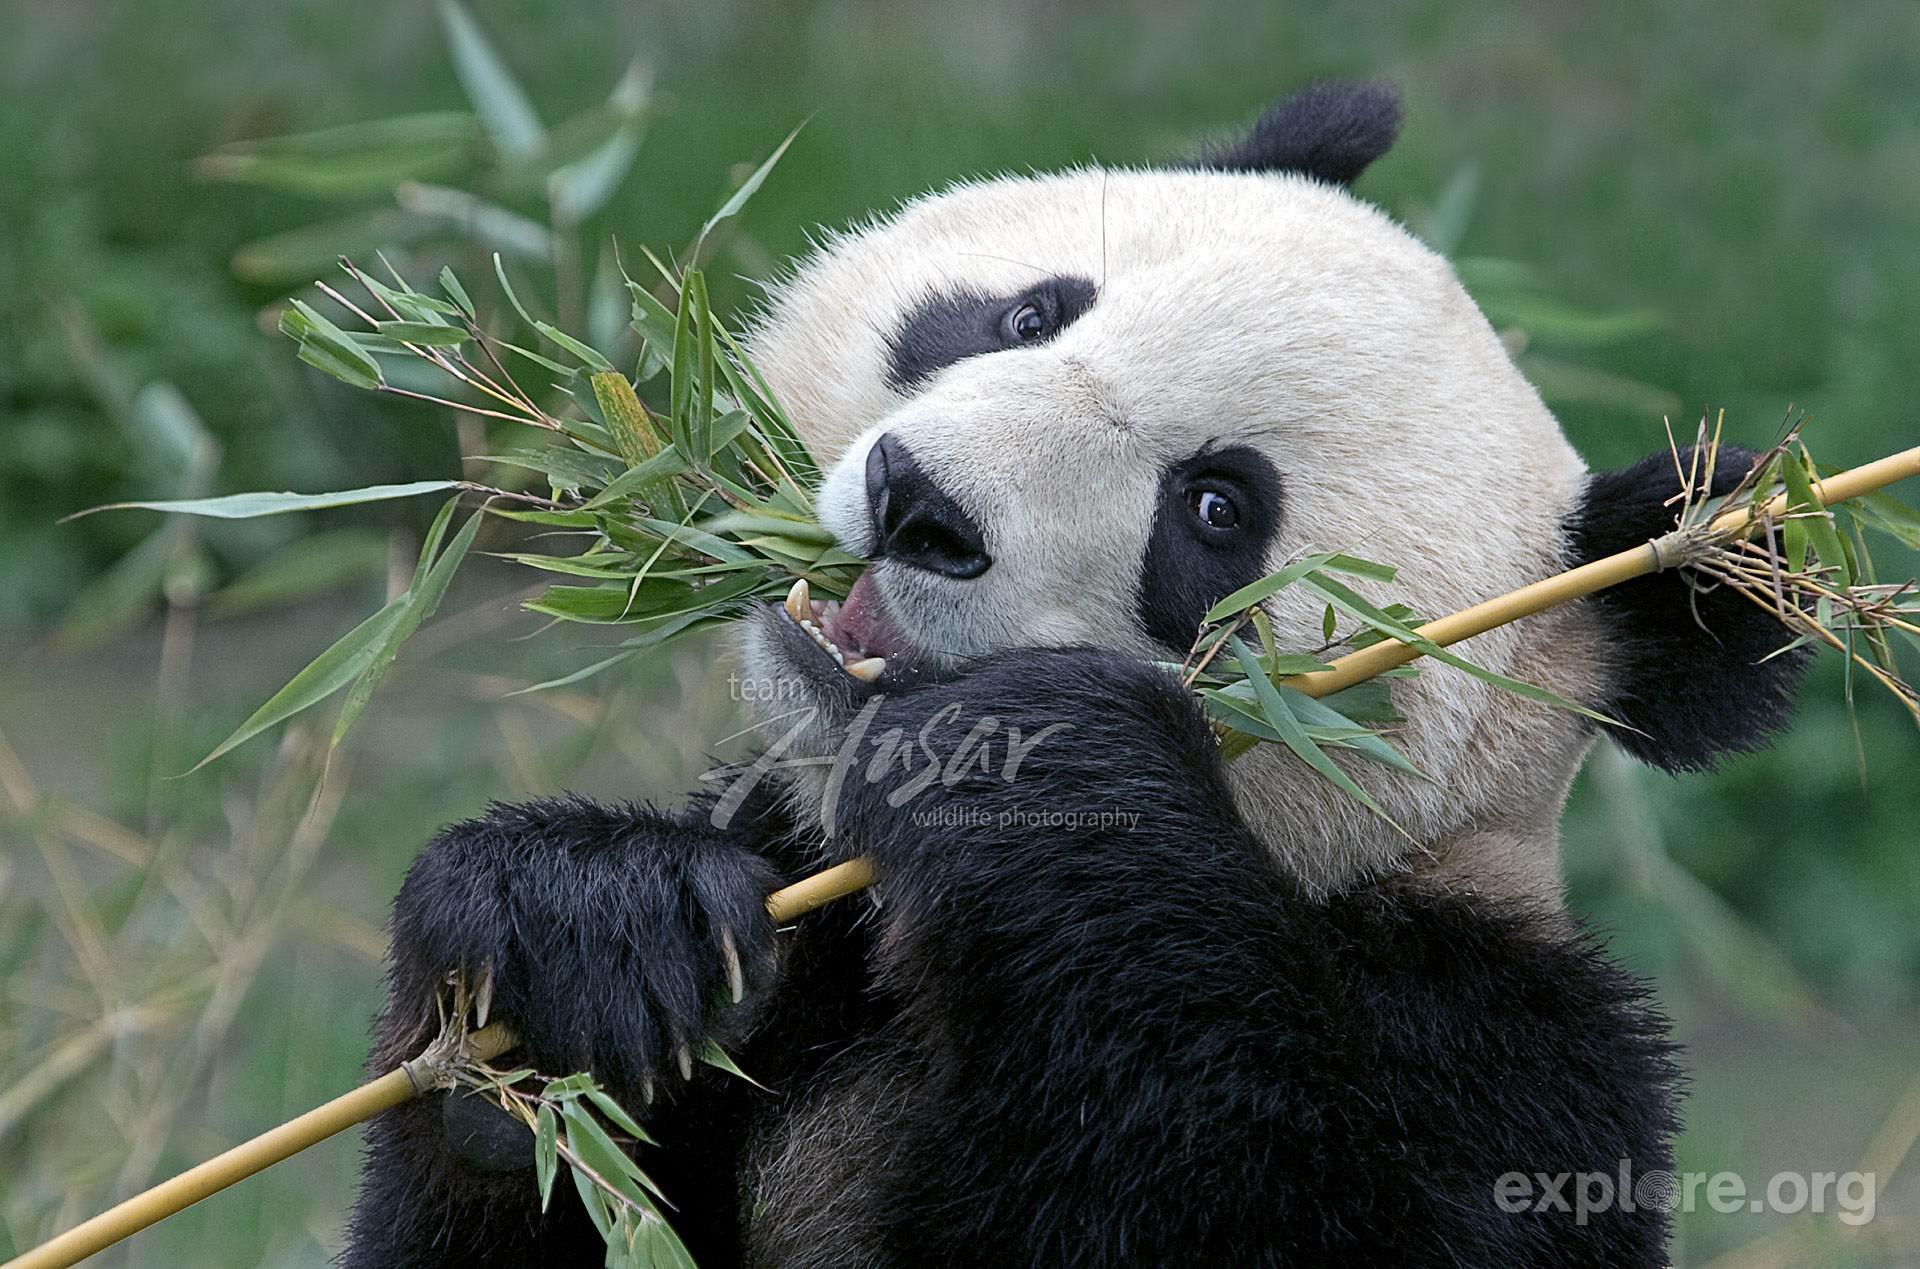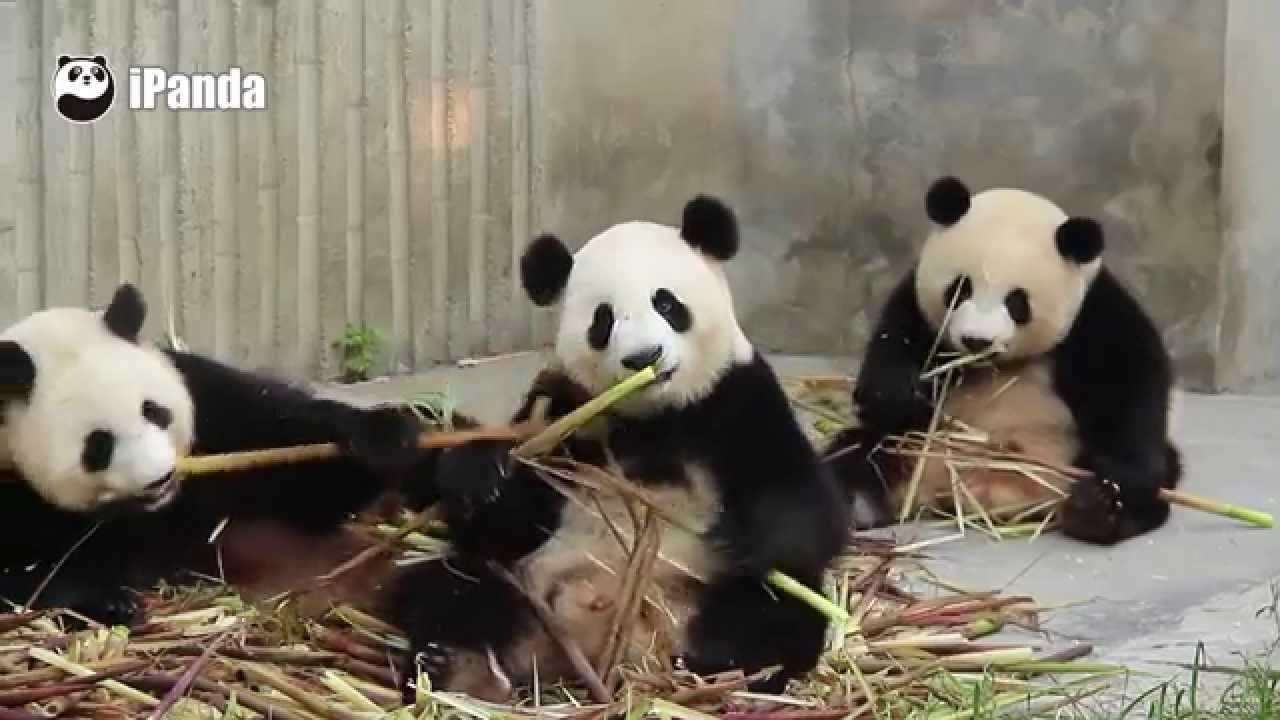The first image is the image on the left, the second image is the image on the right. Analyze the images presented: Is the assertion "The left image contains exactly one panda." valid? Answer yes or no. Yes. The first image is the image on the left, the second image is the image on the right. For the images shown, is this caption "There are more than 4 pandas." true? Answer yes or no. No. 